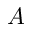Convert formula to latex. <formula><loc_0><loc_0><loc_500><loc_500>A</formula> 